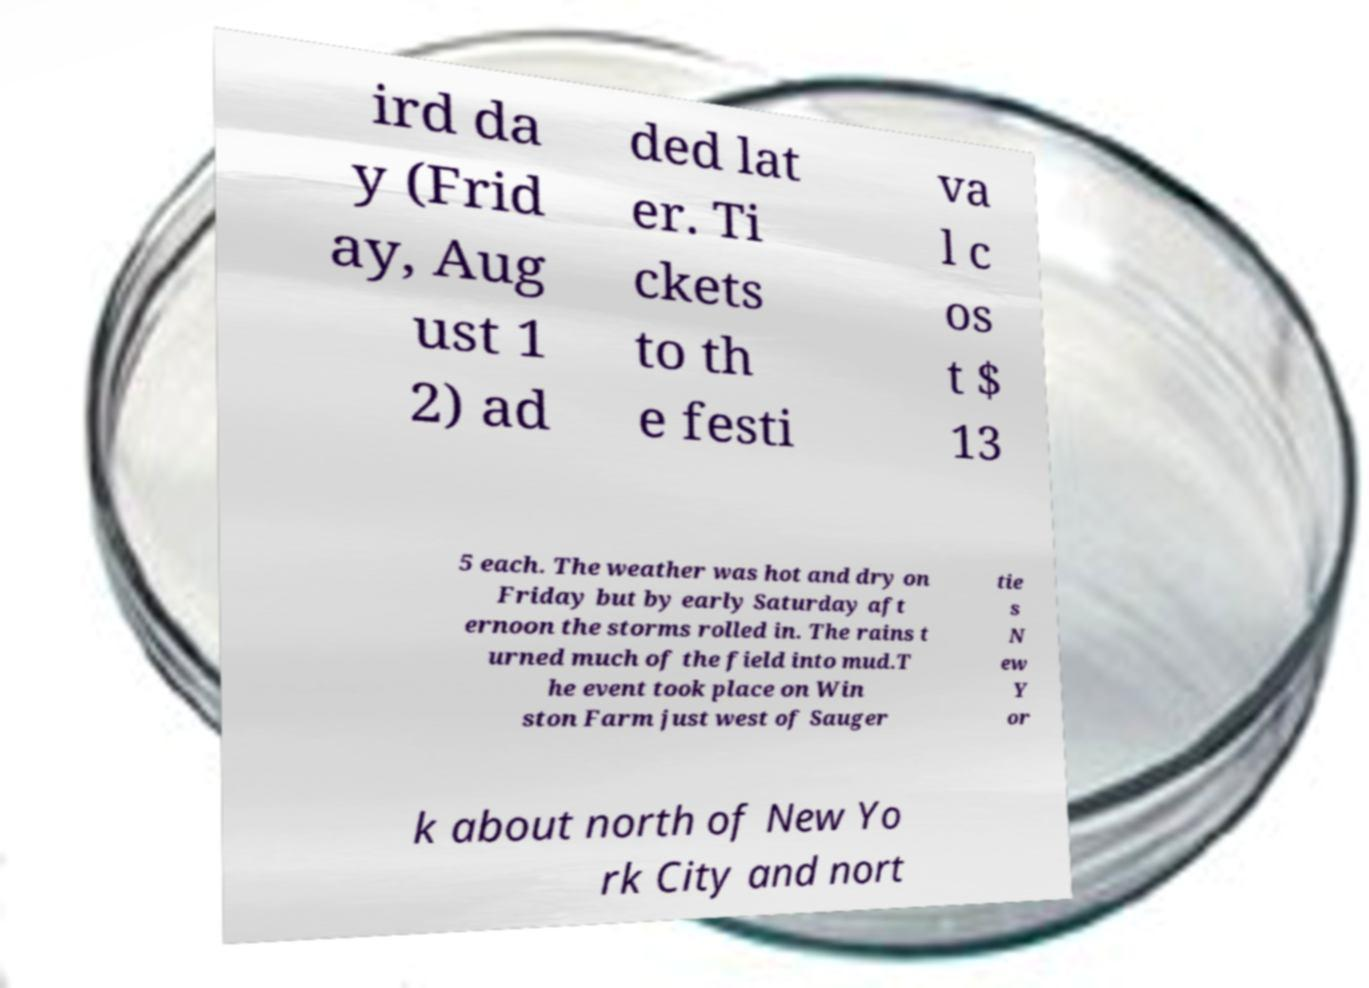For documentation purposes, I need the text within this image transcribed. Could you provide that? ird da y (Frid ay, Aug ust 1 2) ad ded lat er. Ti ckets to th e festi va l c os t $ 13 5 each. The weather was hot and dry on Friday but by early Saturday aft ernoon the storms rolled in. The rains t urned much of the field into mud.T he event took place on Win ston Farm just west of Sauger tie s N ew Y or k about north of New Yo rk City and nort 